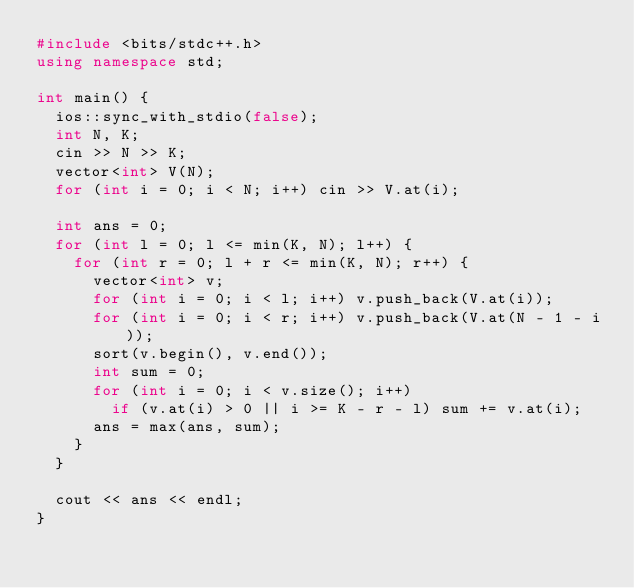<code> <loc_0><loc_0><loc_500><loc_500><_C++_>#include <bits/stdc++.h>
using namespace std;

int main() {
  ios::sync_with_stdio(false);
  int N, K;
  cin >> N >> K;
  vector<int> V(N);
  for (int i = 0; i < N; i++) cin >> V.at(i);

  int ans = 0;
  for (int l = 0; l <= min(K, N); l++) {
    for (int r = 0; l + r <= min(K, N); r++) {
      vector<int> v;
      for (int i = 0; i < l; i++) v.push_back(V.at(i));
      for (int i = 0; i < r; i++) v.push_back(V.at(N - 1 - i));
      sort(v.begin(), v.end());
      int sum = 0;
      for (int i = 0; i < v.size(); i++)
        if (v.at(i) > 0 || i >= K - r - l) sum += v.at(i);
      ans = max(ans, sum);
    }
  }

  cout << ans << endl;
}</code> 